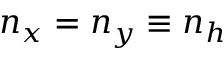<formula> <loc_0><loc_0><loc_500><loc_500>n _ { x } = n _ { y } \equiv n _ { h }</formula> 